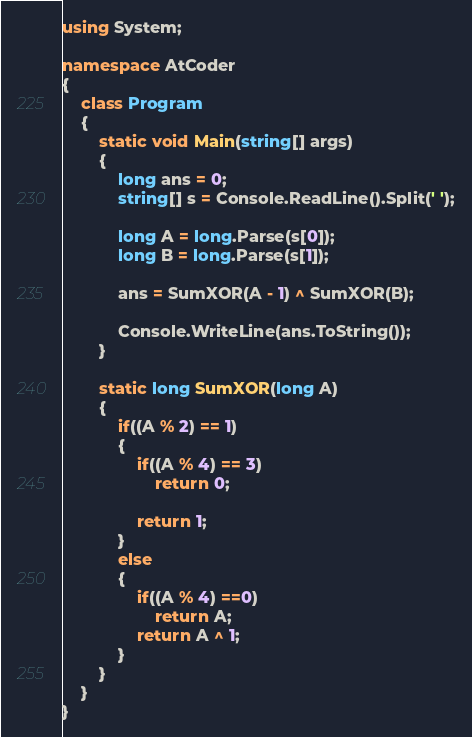<code> <loc_0><loc_0><loc_500><loc_500><_C#_>using System;

namespace AtCoder
{
    class Program
    {
        static void Main(string[] args)
        {
            long ans = 0;
            string[] s = Console.ReadLine().Split(' ');

            long A = long.Parse(s[0]);
            long B = long.Parse(s[1]);

            ans = SumXOR(A - 1) ^ SumXOR(B);

            Console.WriteLine(ans.ToString());
        }

        static long SumXOR(long A)
        {
            if((A % 2) == 1)
            {
                if((A % 4) == 3)
                    return 0;

                return 1;
            }
            else
            {
                if((A % 4) ==0)
                    return A;
                return A ^ 1;
            }
        }
    }
}
</code> 